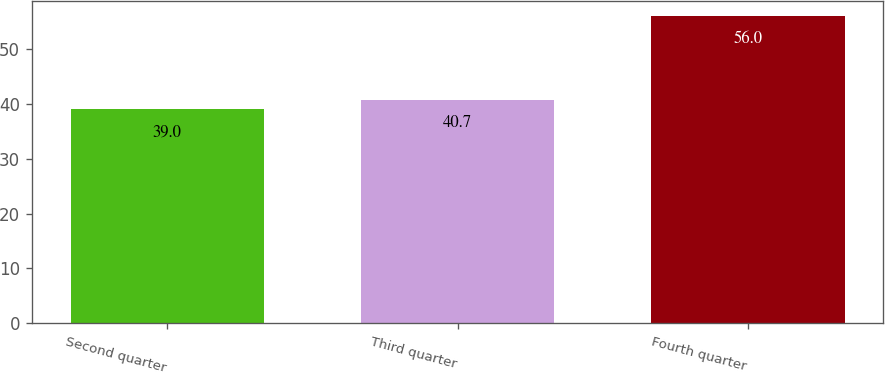Convert chart to OTSL. <chart><loc_0><loc_0><loc_500><loc_500><bar_chart><fcel>Second quarter<fcel>Third quarter<fcel>Fourth quarter<nl><fcel>39<fcel>40.7<fcel>56<nl></chart> 